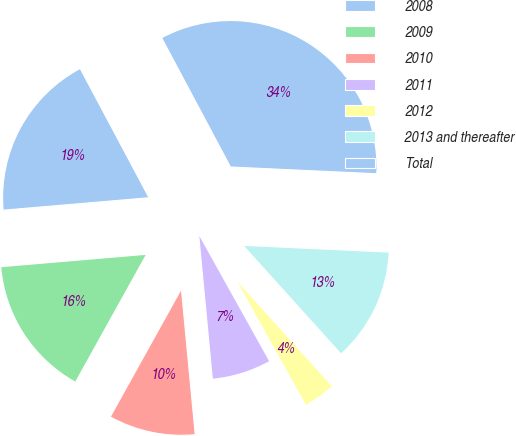<chart> <loc_0><loc_0><loc_500><loc_500><pie_chart><fcel>2008<fcel>2009<fcel>2010<fcel>2011<fcel>2012<fcel>2013 and thereafter<fcel>Total<nl><fcel>18.56%<fcel>15.57%<fcel>9.58%<fcel>6.59%<fcel>3.59%<fcel>12.58%<fcel>33.53%<nl></chart> 